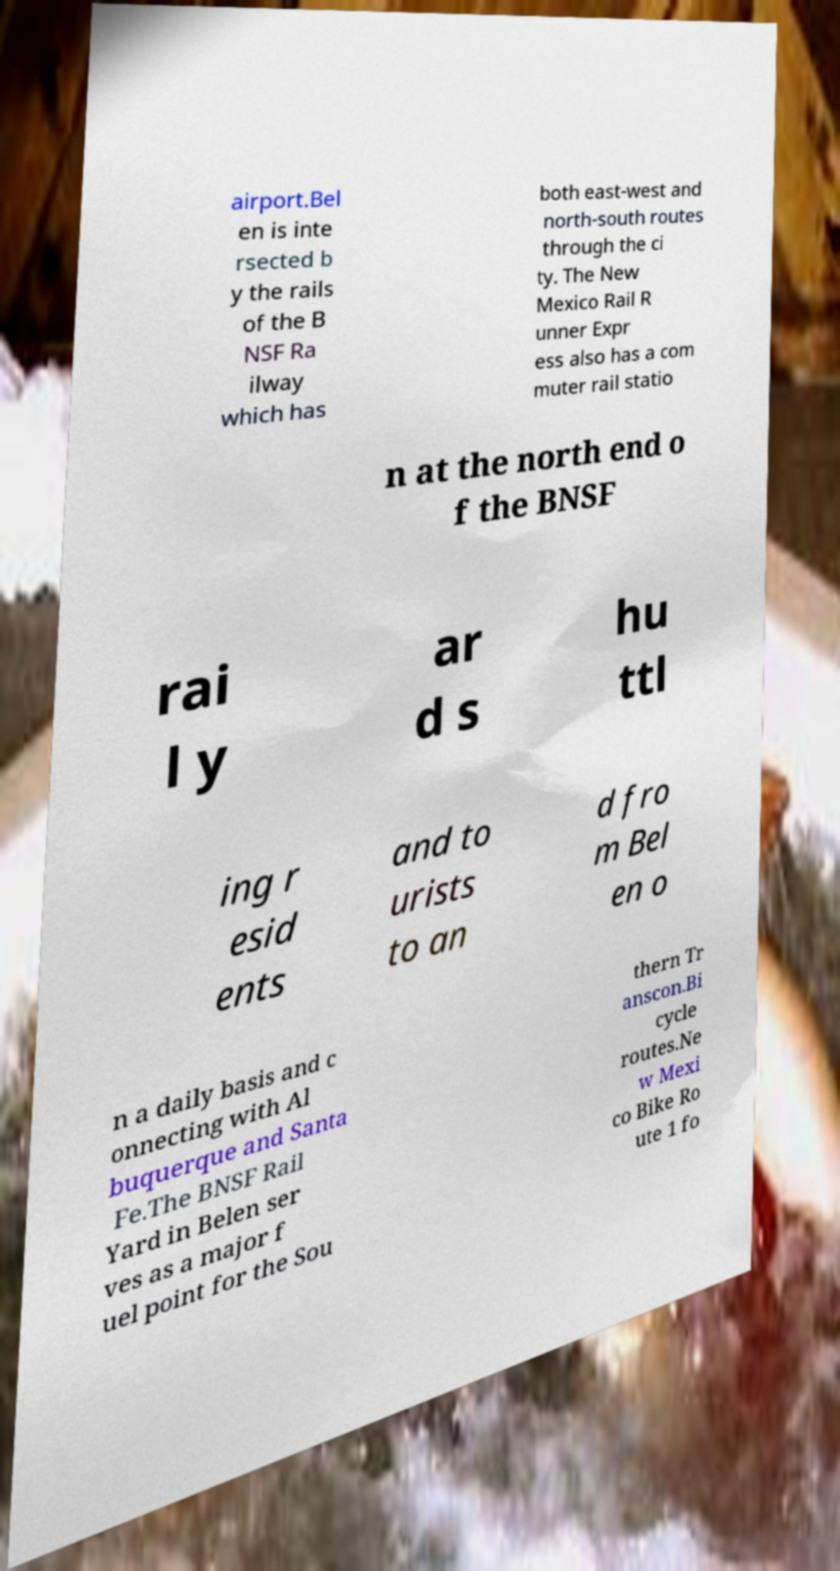There's text embedded in this image that I need extracted. Can you transcribe it verbatim? airport.Bel en is inte rsected b y the rails of the B NSF Ra ilway which has both east-west and north-south routes through the ci ty. The New Mexico Rail R unner Expr ess also has a com muter rail statio n at the north end o f the BNSF rai l y ar d s hu ttl ing r esid ents and to urists to an d fro m Bel en o n a daily basis and c onnecting with Al buquerque and Santa Fe.The BNSF Rail Yard in Belen ser ves as a major f uel point for the Sou thern Tr anscon.Bi cycle routes.Ne w Mexi co Bike Ro ute 1 fo 